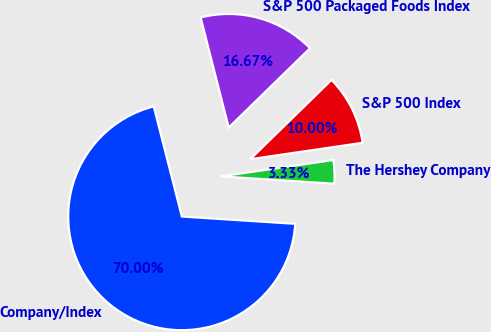Convert chart to OTSL. <chart><loc_0><loc_0><loc_500><loc_500><pie_chart><fcel>Company/Index<fcel>The Hershey Company<fcel>S&P 500 Index<fcel>S&P 500 Packaged Foods Index<nl><fcel>70.0%<fcel>3.33%<fcel>10.0%<fcel>16.67%<nl></chart> 